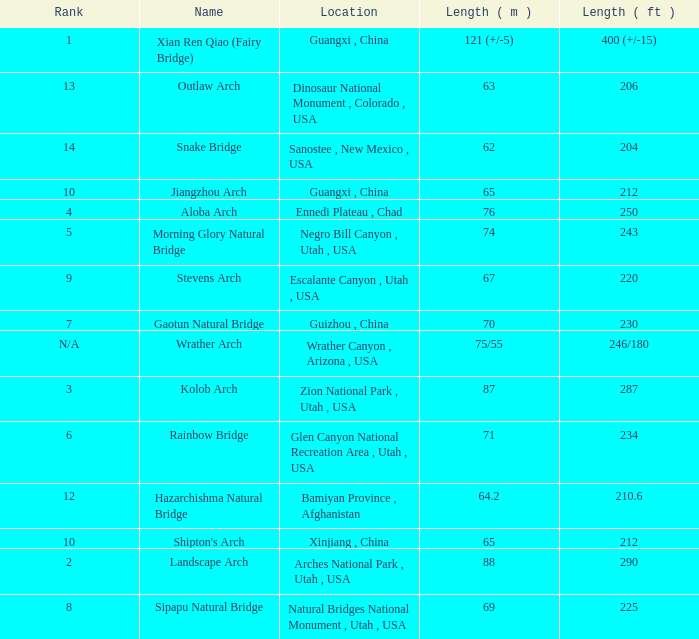Where is the longest arch with a length in meters of 63? Dinosaur National Monument , Colorado , USA. 